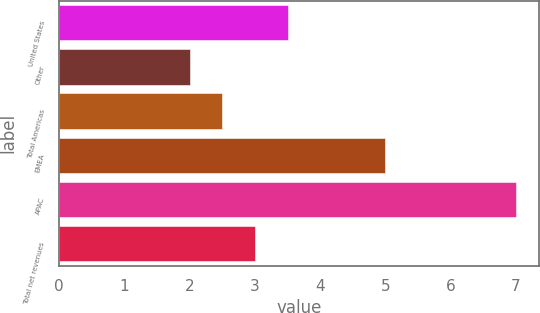<chart> <loc_0><loc_0><loc_500><loc_500><bar_chart><fcel>United States<fcel>Other<fcel>Total Americas<fcel>EMEA<fcel>APAC<fcel>Total net revenues<nl><fcel>3.5<fcel>2<fcel>2.5<fcel>5<fcel>7<fcel>3<nl></chart> 